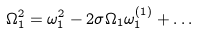Convert formula to latex. <formula><loc_0><loc_0><loc_500><loc_500>\Omega _ { 1 } ^ { 2 } = \omega _ { 1 } ^ { 2 } - 2 \sigma \Omega _ { 1 } \omega _ { 1 } ^ { ( 1 ) } + \dots</formula> 